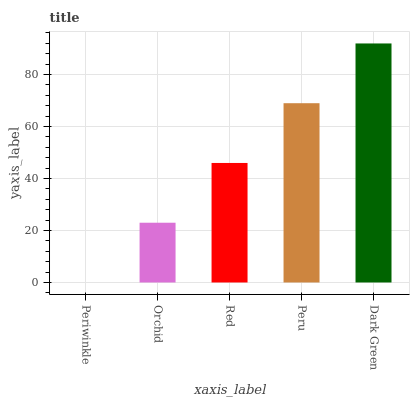Is Periwinkle the minimum?
Answer yes or no. Yes. Is Dark Green the maximum?
Answer yes or no. Yes. Is Orchid the minimum?
Answer yes or no. No. Is Orchid the maximum?
Answer yes or no. No. Is Orchid greater than Periwinkle?
Answer yes or no. Yes. Is Periwinkle less than Orchid?
Answer yes or no. Yes. Is Periwinkle greater than Orchid?
Answer yes or no. No. Is Orchid less than Periwinkle?
Answer yes or no. No. Is Red the high median?
Answer yes or no. Yes. Is Red the low median?
Answer yes or no. Yes. Is Orchid the high median?
Answer yes or no. No. Is Dark Green the low median?
Answer yes or no. No. 